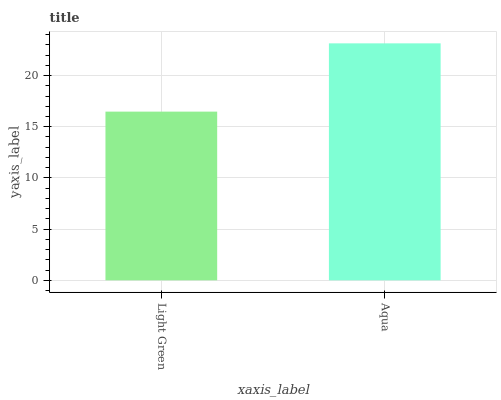Is Aqua the minimum?
Answer yes or no. No. Is Aqua greater than Light Green?
Answer yes or no. Yes. Is Light Green less than Aqua?
Answer yes or no. Yes. Is Light Green greater than Aqua?
Answer yes or no. No. Is Aqua less than Light Green?
Answer yes or no. No. Is Aqua the high median?
Answer yes or no. Yes. Is Light Green the low median?
Answer yes or no. Yes. Is Light Green the high median?
Answer yes or no. No. Is Aqua the low median?
Answer yes or no. No. 